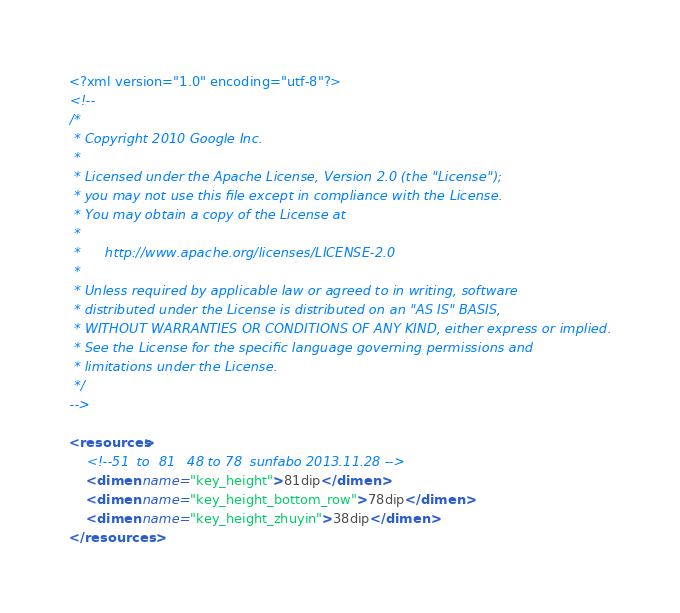<code> <loc_0><loc_0><loc_500><loc_500><_XML_><?xml version="1.0" encoding="utf-8"?>
<!--
/*
 * Copyright 2010 Google Inc.
 *
 * Licensed under the Apache License, Version 2.0 (the "License");
 * you may not use this file except in compliance with the License.
 * You may obtain a copy of the License at
 *
 *      http://www.apache.org/licenses/LICENSE-2.0
 *
 * Unless required by applicable law or agreed to in writing, software
 * distributed under the License is distributed on an "AS IS" BASIS,
 * WITHOUT WARRANTIES OR CONDITIONS OF ANY KIND, either express or implied.
 * See the License for the specific language governing permissions and
 * limitations under the License.
 */
-->

<resources>
    <!--51  to  81   48 to 78  sunfabo 2013.11.28 -->
    <dimen name="key_height">81dip</dimen>
    <dimen name="key_height_bottom_row">78dip</dimen>
    <dimen name="key_height_zhuyin">38dip</dimen>
</resources>
</code> 